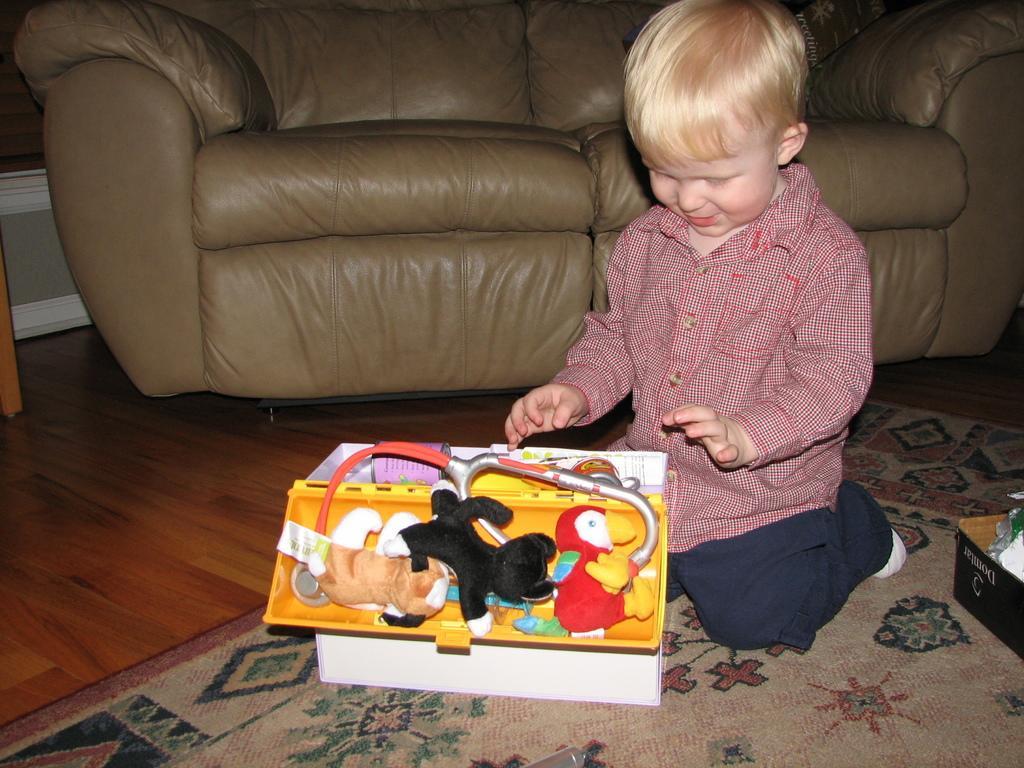How would you summarize this image in a sentence or two? In the foreground of this image, there is a boy kneel downing on a mat and there are toys and a kit in front of him and there is a card board box beside him. In the background, there is a couch and the floor. 